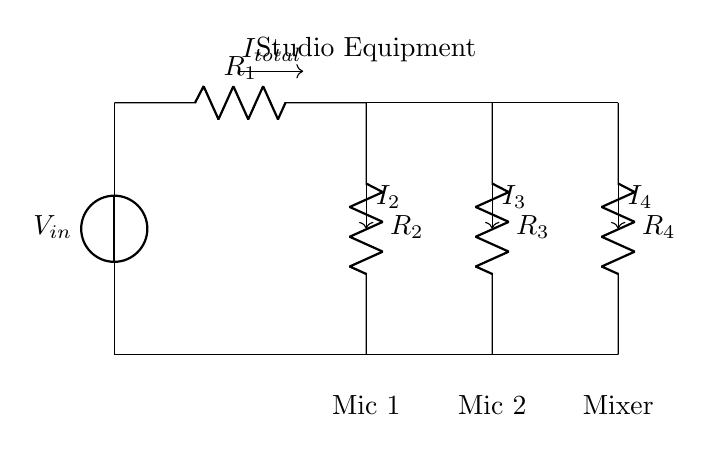What is the input voltage in the circuit? The input voltage is labeled as V_in, which represents the voltage source supplying the circuit.
Answer: V_in How many resistors are present in this circuit? There are four resistors labeled R1, R2, R3, and R4 in the diagram.
Answer: Four What is the purpose of the current divider in this circuit? The current divider allows the input current to be distributed among multiple branches, providing different current levels to each connected device.
Answer: To distribute current How can the total current flowing into the circuit be defined? The total current I_total flowing into the circuit is the sum of the currents I2, I3, and I4 flowing through each parallel branch, based on the principle of parallel circuits.
Answer: I_total = I2 + I3 + I4 Which components are connected to resistors R2, R3, and R4? Mic 1 is connected to R2, Mic 2 is connected to R3, and the Mixer is connected to R4.
Answer: Mic 1, Mic 2, Mixer If R1 is 10 ohms and R2 is 20 ohms, how would you determine the current through R2? First, calculate the total resistance of the circuit using the resistance values. Then, apply the current divider rule, which states that the current through a resistor in parallel is inversely proportional to its resistance. Therefore, I2 can be found by the formula I2 = I_total * (R_total / R2).
Answer: Apply current divider rule What is the significance of the 'I_total' arrow in the circuit diagram? The 'I_total' arrow indicates the direction and magnitude of the total current entering the parallel branches of the circuit, which splits into the various currents (I2, I3, and I4) flowing to the microphones and mixer.
Answer: Indicates total current 